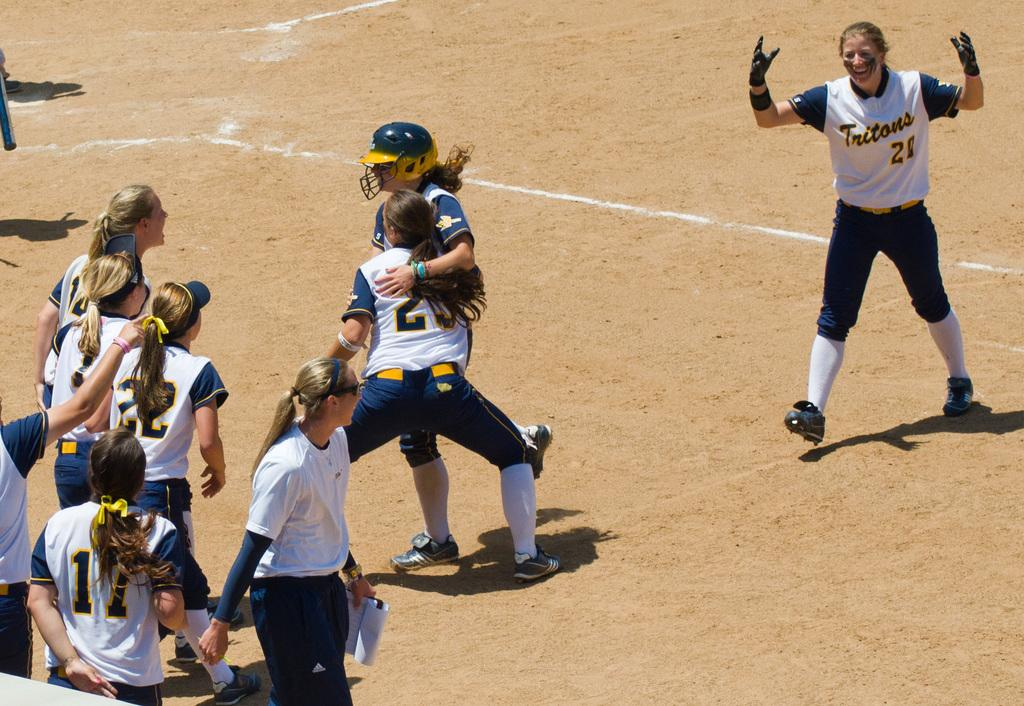<image>
Provide a brief description of the given image. A girl with the number 22 on the back of her jersey is on the field with her teammates. 